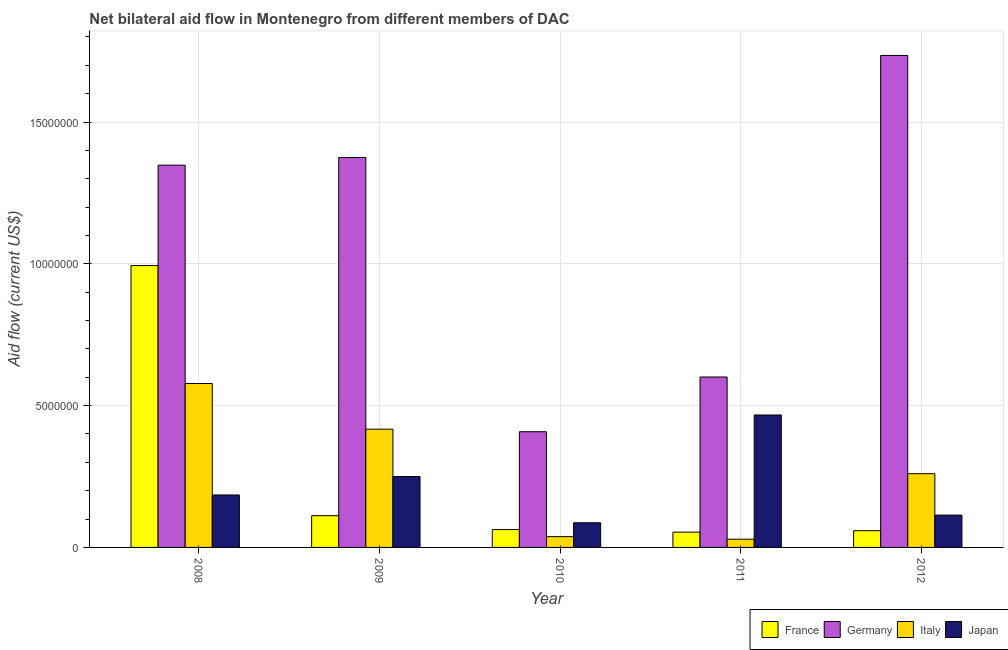How many different coloured bars are there?
Your answer should be compact. 4. Are the number of bars per tick equal to the number of legend labels?
Keep it short and to the point. Yes. How many bars are there on the 2nd tick from the left?
Keep it short and to the point. 4. How many bars are there on the 5th tick from the right?
Your answer should be very brief. 4. In how many cases, is the number of bars for a given year not equal to the number of legend labels?
Your answer should be very brief. 0. What is the amount of aid given by italy in 2010?
Keep it short and to the point. 3.80e+05. Across all years, what is the maximum amount of aid given by japan?
Give a very brief answer. 4.67e+06. Across all years, what is the minimum amount of aid given by italy?
Offer a terse response. 2.90e+05. What is the total amount of aid given by japan in the graph?
Your response must be concise. 1.10e+07. What is the difference between the amount of aid given by japan in 2008 and that in 2012?
Your response must be concise. 7.10e+05. What is the difference between the amount of aid given by france in 2012 and the amount of aid given by japan in 2011?
Give a very brief answer. 5.00e+04. What is the average amount of aid given by japan per year?
Ensure brevity in your answer.  2.21e+06. In the year 2009, what is the difference between the amount of aid given by france and amount of aid given by japan?
Offer a terse response. 0. What is the ratio of the amount of aid given by france in 2009 to that in 2011?
Provide a succinct answer. 2.07. Is the difference between the amount of aid given by japan in 2010 and 2011 greater than the difference between the amount of aid given by italy in 2010 and 2011?
Make the answer very short. No. What is the difference between the highest and the second highest amount of aid given by italy?
Provide a succinct answer. 1.61e+06. What is the difference between the highest and the lowest amount of aid given by germany?
Keep it short and to the point. 1.33e+07. Is it the case that in every year, the sum of the amount of aid given by france and amount of aid given by germany is greater than the amount of aid given by italy?
Your answer should be compact. Yes. What is the difference between two consecutive major ticks on the Y-axis?
Your answer should be compact. 5.00e+06. Does the graph contain grids?
Your response must be concise. Yes. How many legend labels are there?
Make the answer very short. 4. How are the legend labels stacked?
Provide a succinct answer. Horizontal. What is the title of the graph?
Give a very brief answer. Net bilateral aid flow in Montenegro from different members of DAC. Does "Regional development banks" appear as one of the legend labels in the graph?
Your response must be concise. No. What is the label or title of the Y-axis?
Your response must be concise. Aid flow (current US$). What is the Aid flow (current US$) of France in 2008?
Your answer should be compact. 9.94e+06. What is the Aid flow (current US$) of Germany in 2008?
Your response must be concise. 1.35e+07. What is the Aid flow (current US$) of Italy in 2008?
Make the answer very short. 5.78e+06. What is the Aid flow (current US$) of Japan in 2008?
Provide a succinct answer. 1.85e+06. What is the Aid flow (current US$) in France in 2009?
Your response must be concise. 1.12e+06. What is the Aid flow (current US$) of Germany in 2009?
Provide a succinct answer. 1.38e+07. What is the Aid flow (current US$) of Italy in 2009?
Your answer should be very brief. 4.17e+06. What is the Aid flow (current US$) in Japan in 2009?
Ensure brevity in your answer.  2.50e+06. What is the Aid flow (current US$) of France in 2010?
Your answer should be very brief. 6.30e+05. What is the Aid flow (current US$) of Germany in 2010?
Make the answer very short. 4.08e+06. What is the Aid flow (current US$) of Italy in 2010?
Give a very brief answer. 3.80e+05. What is the Aid flow (current US$) of Japan in 2010?
Provide a short and direct response. 8.70e+05. What is the Aid flow (current US$) of France in 2011?
Make the answer very short. 5.40e+05. What is the Aid flow (current US$) in Germany in 2011?
Provide a short and direct response. 6.01e+06. What is the Aid flow (current US$) in Japan in 2011?
Your answer should be compact. 4.67e+06. What is the Aid flow (current US$) of France in 2012?
Provide a succinct answer. 5.90e+05. What is the Aid flow (current US$) of Germany in 2012?
Give a very brief answer. 1.74e+07. What is the Aid flow (current US$) in Italy in 2012?
Make the answer very short. 2.60e+06. What is the Aid flow (current US$) of Japan in 2012?
Offer a very short reply. 1.14e+06. Across all years, what is the maximum Aid flow (current US$) of France?
Your answer should be very brief. 9.94e+06. Across all years, what is the maximum Aid flow (current US$) in Germany?
Provide a succinct answer. 1.74e+07. Across all years, what is the maximum Aid flow (current US$) in Italy?
Offer a very short reply. 5.78e+06. Across all years, what is the maximum Aid flow (current US$) of Japan?
Give a very brief answer. 4.67e+06. Across all years, what is the minimum Aid flow (current US$) in France?
Make the answer very short. 5.40e+05. Across all years, what is the minimum Aid flow (current US$) in Germany?
Offer a very short reply. 4.08e+06. Across all years, what is the minimum Aid flow (current US$) of Italy?
Provide a short and direct response. 2.90e+05. Across all years, what is the minimum Aid flow (current US$) of Japan?
Your answer should be very brief. 8.70e+05. What is the total Aid flow (current US$) in France in the graph?
Your response must be concise. 1.28e+07. What is the total Aid flow (current US$) of Germany in the graph?
Your answer should be compact. 5.47e+07. What is the total Aid flow (current US$) in Italy in the graph?
Your answer should be compact. 1.32e+07. What is the total Aid flow (current US$) of Japan in the graph?
Provide a short and direct response. 1.10e+07. What is the difference between the Aid flow (current US$) in France in 2008 and that in 2009?
Offer a very short reply. 8.82e+06. What is the difference between the Aid flow (current US$) in Italy in 2008 and that in 2009?
Provide a succinct answer. 1.61e+06. What is the difference between the Aid flow (current US$) of Japan in 2008 and that in 2009?
Make the answer very short. -6.50e+05. What is the difference between the Aid flow (current US$) of France in 2008 and that in 2010?
Provide a succinct answer. 9.31e+06. What is the difference between the Aid flow (current US$) in Germany in 2008 and that in 2010?
Provide a succinct answer. 9.40e+06. What is the difference between the Aid flow (current US$) in Italy in 2008 and that in 2010?
Keep it short and to the point. 5.40e+06. What is the difference between the Aid flow (current US$) of Japan in 2008 and that in 2010?
Give a very brief answer. 9.80e+05. What is the difference between the Aid flow (current US$) in France in 2008 and that in 2011?
Keep it short and to the point. 9.40e+06. What is the difference between the Aid flow (current US$) of Germany in 2008 and that in 2011?
Make the answer very short. 7.47e+06. What is the difference between the Aid flow (current US$) in Italy in 2008 and that in 2011?
Provide a succinct answer. 5.49e+06. What is the difference between the Aid flow (current US$) in Japan in 2008 and that in 2011?
Make the answer very short. -2.82e+06. What is the difference between the Aid flow (current US$) in France in 2008 and that in 2012?
Your answer should be compact. 9.35e+06. What is the difference between the Aid flow (current US$) in Germany in 2008 and that in 2012?
Offer a terse response. -3.87e+06. What is the difference between the Aid flow (current US$) in Italy in 2008 and that in 2012?
Your response must be concise. 3.18e+06. What is the difference between the Aid flow (current US$) in Japan in 2008 and that in 2012?
Offer a very short reply. 7.10e+05. What is the difference between the Aid flow (current US$) in France in 2009 and that in 2010?
Offer a very short reply. 4.90e+05. What is the difference between the Aid flow (current US$) in Germany in 2009 and that in 2010?
Make the answer very short. 9.67e+06. What is the difference between the Aid flow (current US$) of Italy in 2009 and that in 2010?
Make the answer very short. 3.79e+06. What is the difference between the Aid flow (current US$) of Japan in 2009 and that in 2010?
Ensure brevity in your answer.  1.63e+06. What is the difference between the Aid flow (current US$) in France in 2009 and that in 2011?
Provide a short and direct response. 5.80e+05. What is the difference between the Aid flow (current US$) of Germany in 2009 and that in 2011?
Your answer should be very brief. 7.74e+06. What is the difference between the Aid flow (current US$) of Italy in 2009 and that in 2011?
Keep it short and to the point. 3.88e+06. What is the difference between the Aid flow (current US$) of Japan in 2009 and that in 2011?
Your answer should be very brief. -2.17e+06. What is the difference between the Aid flow (current US$) of France in 2009 and that in 2012?
Give a very brief answer. 5.30e+05. What is the difference between the Aid flow (current US$) of Germany in 2009 and that in 2012?
Your answer should be very brief. -3.60e+06. What is the difference between the Aid flow (current US$) in Italy in 2009 and that in 2012?
Keep it short and to the point. 1.57e+06. What is the difference between the Aid flow (current US$) in Japan in 2009 and that in 2012?
Your response must be concise. 1.36e+06. What is the difference between the Aid flow (current US$) of France in 2010 and that in 2011?
Offer a very short reply. 9.00e+04. What is the difference between the Aid flow (current US$) in Germany in 2010 and that in 2011?
Give a very brief answer. -1.93e+06. What is the difference between the Aid flow (current US$) in Japan in 2010 and that in 2011?
Your answer should be compact. -3.80e+06. What is the difference between the Aid flow (current US$) of France in 2010 and that in 2012?
Offer a terse response. 4.00e+04. What is the difference between the Aid flow (current US$) of Germany in 2010 and that in 2012?
Offer a terse response. -1.33e+07. What is the difference between the Aid flow (current US$) in Italy in 2010 and that in 2012?
Ensure brevity in your answer.  -2.22e+06. What is the difference between the Aid flow (current US$) of Japan in 2010 and that in 2012?
Keep it short and to the point. -2.70e+05. What is the difference between the Aid flow (current US$) in France in 2011 and that in 2012?
Offer a terse response. -5.00e+04. What is the difference between the Aid flow (current US$) of Germany in 2011 and that in 2012?
Provide a short and direct response. -1.13e+07. What is the difference between the Aid flow (current US$) of Italy in 2011 and that in 2012?
Offer a terse response. -2.31e+06. What is the difference between the Aid flow (current US$) of Japan in 2011 and that in 2012?
Keep it short and to the point. 3.53e+06. What is the difference between the Aid flow (current US$) of France in 2008 and the Aid flow (current US$) of Germany in 2009?
Provide a succinct answer. -3.81e+06. What is the difference between the Aid flow (current US$) in France in 2008 and the Aid flow (current US$) in Italy in 2009?
Give a very brief answer. 5.77e+06. What is the difference between the Aid flow (current US$) in France in 2008 and the Aid flow (current US$) in Japan in 2009?
Ensure brevity in your answer.  7.44e+06. What is the difference between the Aid flow (current US$) of Germany in 2008 and the Aid flow (current US$) of Italy in 2009?
Offer a very short reply. 9.31e+06. What is the difference between the Aid flow (current US$) of Germany in 2008 and the Aid flow (current US$) of Japan in 2009?
Provide a succinct answer. 1.10e+07. What is the difference between the Aid flow (current US$) in Italy in 2008 and the Aid flow (current US$) in Japan in 2009?
Your response must be concise. 3.28e+06. What is the difference between the Aid flow (current US$) in France in 2008 and the Aid flow (current US$) in Germany in 2010?
Your answer should be compact. 5.86e+06. What is the difference between the Aid flow (current US$) of France in 2008 and the Aid flow (current US$) of Italy in 2010?
Your answer should be compact. 9.56e+06. What is the difference between the Aid flow (current US$) of France in 2008 and the Aid flow (current US$) of Japan in 2010?
Give a very brief answer. 9.07e+06. What is the difference between the Aid flow (current US$) in Germany in 2008 and the Aid flow (current US$) in Italy in 2010?
Make the answer very short. 1.31e+07. What is the difference between the Aid flow (current US$) of Germany in 2008 and the Aid flow (current US$) of Japan in 2010?
Ensure brevity in your answer.  1.26e+07. What is the difference between the Aid flow (current US$) in Italy in 2008 and the Aid flow (current US$) in Japan in 2010?
Your answer should be very brief. 4.91e+06. What is the difference between the Aid flow (current US$) of France in 2008 and the Aid flow (current US$) of Germany in 2011?
Keep it short and to the point. 3.93e+06. What is the difference between the Aid flow (current US$) in France in 2008 and the Aid flow (current US$) in Italy in 2011?
Your response must be concise. 9.65e+06. What is the difference between the Aid flow (current US$) of France in 2008 and the Aid flow (current US$) of Japan in 2011?
Keep it short and to the point. 5.27e+06. What is the difference between the Aid flow (current US$) in Germany in 2008 and the Aid flow (current US$) in Italy in 2011?
Your answer should be compact. 1.32e+07. What is the difference between the Aid flow (current US$) of Germany in 2008 and the Aid flow (current US$) of Japan in 2011?
Ensure brevity in your answer.  8.81e+06. What is the difference between the Aid flow (current US$) in Italy in 2008 and the Aid flow (current US$) in Japan in 2011?
Your response must be concise. 1.11e+06. What is the difference between the Aid flow (current US$) in France in 2008 and the Aid flow (current US$) in Germany in 2012?
Provide a short and direct response. -7.41e+06. What is the difference between the Aid flow (current US$) of France in 2008 and the Aid flow (current US$) of Italy in 2012?
Provide a succinct answer. 7.34e+06. What is the difference between the Aid flow (current US$) in France in 2008 and the Aid flow (current US$) in Japan in 2012?
Give a very brief answer. 8.80e+06. What is the difference between the Aid flow (current US$) of Germany in 2008 and the Aid flow (current US$) of Italy in 2012?
Give a very brief answer. 1.09e+07. What is the difference between the Aid flow (current US$) in Germany in 2008 and the Aid flow (current US$) in Japan in 2012?
Ensure brevity in your answer.  1.23e+07. What is the difference between the Aid flow (current US$) of Italy in 2008 and the Aid flow (current US$) of Japan in 2012?
Make the answer very short. 4.64e+06. What is the difference between the Aid flow (current US$) of France in 2009 and the Aid flow (current US$) of Germany in 2010?
Offer a terse response. -2.96e+06. What is the difference between the Aid flow (current US$) in France in 2009 and the Aid flow (current US$) in Italy in 2010?
Give a very brief answer. 7.40e+05. What is the difference between the Aid flow (current US$) of Germany in 2009 and the Aid flow (current US$) of Italy in 2010?
Provide a short and direct response. 1.34e+07. What is the difference between the Aid flow (current US$) in Germany in 2009 and the Aid flow (current US$) in Japan in 2010?
Your answer should be very brief. 1.29e+07. What is the difference between the Aid flow (current US$) of Italy in 2009 and the Aid flow (current US$) of Japan in 2010?
Your answer should be very brief. 3.30e+06. What is the difference between the Aid flow (current US$) in France in 2009 and the Aid flow (current US$) in Germany in 2011?
Offer a terse response. -4.89e+06. What is the difference between the Aid flow (current US$) in France in 2009 and the Aid flow (current US$) in Italy in 2011?
Provide a succinct answer. 8.30e+05. What is the difference between the Aid flow (current US$) in France in 2009 and the Aid flow (current US$) in Japan in 2011?
Your response must be concise. -3.55e+06. What is the difference between the Aid flow (current US$) of Germany in 2009 and the Aid flow (current US$) of Italy in 2011?
Ensure brevity in your answer.  1.35e+07. What is the difference between the Aid flow (current US$) in Germany in 2009 and the Aid flow (current US$) in Japan in 2011?
Provide a succinct answer. 9.08e+06. What is the difference between the Aid flow (current US$) of Italy in 2009 and the Aid flow (current US$) of Japan in 2011?
Your response must be concise. -5.00e+05. What is the difference between the Aid flow (current US$) in France in 2009 and the Aid flow (current US$) in Germany in 2012?
Your answer should be very brief. -1.62e+07. What is the difference between the Aid flow (current US$) of France in 2009 and the Aid flow (current US$) of Italy in 2012?
Offer a very short reply. -1.48e+06. What is the difference between the Aid flow (current US$) in France in 2009 and the Aid flow (current US$) in Japan in 2012?
Offer a terse response. -2.00e+04. What is the difference between the Aid flow (current US$) in Germany in 2009 and the Aid flow (current US$) in Italy in 2012?
Provide a short and direct response. 1.12e+07. What is the difference between the Aid flow (current US$) in Germany in 2009 and the Aid flow (current US$) in Japan in 2012?
Keep it short and to the point. 1.26e+07. What is the difference between the Aid flow (current US$) of Italy in 2009 and the Aid flow (current US$) of Japan in 2012?
Offer a terse response. 3.03e+06. What is the difference between the Aid flow (current US$) in France in 2010 and the Aid flow (current US$) in Germany in 2011?
Keep it short and to the point. -5.38e+06. What is the difference between the Aid flow (current US$) in France in 2010 and the Aid flow (current US$) in Japan in 2011?
Offer a terse response. -4.04e+06. What is the difference between the Aid flow (current US$) in Germany in 2010 and the Aid flow (current US$) in Italy in 2011?
Ensure brevity in your answer.  3.79e+06. What is the difference between the Aid flow (current US$) of Germany in 2010 and the Aid flow (current US$) of Japan in 2011?
Ensure brevity in your answer.  -5.90e+05. What is the difference between the Aid flow (current US$) of Italy in 2010 and the Aid flow (current US$) of Japan in 2011?
Your response must be concise. -4.29e+06. What is the difference between the Aid flow (current US$) of France in 2010 and the Aid flow (current US$) of Germany in 2012?
Your answer should be very brief. -1.67e+07. What is the difference between the Aid flow (current US$) of France in 2010 and the Aid flow (current US$) of Italy in 2012?
Your answer should be very brief. -1.97e+06. What is the difference between the Aid flow (current US$) of France in 2010 and the Aid flow (current US$) of Japan in 2012?
Provide a short and direct response. -5.10e+05. What is the difference between the Aid flow (current US$) in Germany in 2010 and the Aid flow (current US$) in Italy in 2012?
Your response must be concise. 1.48e+06. What is the difference between the Aid flow (current US$) of Germany in 2010 and the Aid flow (current US$) of Japan in 2012?
Provide a succinct answer. 2.94e+06. What is the difference between the Aid flow (current US$) in Italy in 2010 and the Aid flow (current US$) in Japan in 2012?
Provide a short and direct response. -7.60e+05. What is the difference between the Aid flow (current US$) of France in 2011 and the Aid flow (current US$) of Germany in 2012?
Keep it short and to the point. -1.68e+07. What is the difference between the Aid flow (current US$) of France in 2011 and the Aid flow (current US$) of Italy in 2012?
Provide a short and direct response. -2.06e+06. What is the difference between the Aid flow (current US$) of France in 2011 and the Aid flow (current US$) of Japan in 2012?
Keep it short and to the point. -6.00e+05. What is the difference between the Aid flow (current US$) in Germany in 2011 and the Aid flow (current US$) in Italy in 2012?
Give a very brief answer. 3.41e+06. What is the difference between the Aid flow (current US$) of Germany in 2011 and the Aid flow (current US$) of Japan in 2012?
Your answer should be very brief. 4.87e+06. What is the difference between the Aid flow (current US$) of Italy in 2011 and the Aid flow (current US$) of Japan in 2012?
Make the answer very short. -8.50e+05. What is the average Aid flow (current US$) of France per year?
Provide a succinct answer. 2.56e+06. What is the average Aid flow (current US$) in Germany per year?
Make the answer very short. 1.09e+07. What is the average Aid flow (current US$) in Italy per year?
Ensure brevity in your answer.  2.64e+06. What is the average Aid flow (current US$) of Japan per year?
Your response must be concise. 2.21e+06. In the year 2008, what is the difference between the Aid flow (current US$) of France and Aid flow (current US$) of Germany?
Your answer should be very brief. -3.54e+06. In the year 2008, what is the difference between the Aid flow (current US$) of France and Aid flow (current US$) of Italy?
Keep it short and to the point. 4.16e+06. In the year 2008, what is the difference between the Aid flow (current US$) of France and Aid flow (current US$) of Japan?
Your answer should be very brief. 8.09e+06. In the year 2008, what is the difference between the Aid flow (current US$) of Germany and Aid flow (current US$) of Italy?
Provide a short and direct response. 7.70e+06. In the year 2008, what is the difference between the Aid flow (current US$) of Germany and Aid flow (current US$) of Japan?
Offer a terse response. 1.16e+07. In the year 2008, what is the difference between the Aid flow (current US$) of Italy and Aid flow (current US$) of Japan?
Make the answer very short. 3.93e+06. In the year 2009, what is the difference between the Aid flow (current US$) in France and Aid flow (current US$) in Germany?
Provide a short and direct response. -1.26e+07. In the year 2009, what is the difference between the Aid flow (current US$) of France and Aid flow (current US$) of Italy?
Make the answer very short. -3.05e+06. In the year 2009, what is the difference between the Aid flow (current US$) in France and Aid flow (current US$) in Japan?
Your answer should be very brief. -1.38e+06. In the year 2009, what is the difference between the Aid flow (current US$) of Germany and Aid flow (current US$) of Italy?
Keep it short and to the point. 9.58e+06. In the year 2009, what is the difference between the Aid flow (current US$) in Germany and Aid flow (current US$) in Japan?
Keep it short and to the point. 1.12e+07. In the year 2009, what is the difference between the Aid flow (current US$) in Italy and Aid flow (current US$) in Japan?
Keep it short and to the point. 1.67e+06. In the year 2010, what is the difference between the Aid flow (current US$) in France and Aid flow (current US$) in Germany?
Your answer should be very brief. -3.45e+06. In the year 2010, what is the difference between the Aid flow (current US$) in Germany and Aid flow (current US$) in Italy?
Your answer should be compact. 3.70e+06. In the year 2010, what is the difference between the Aid flow (current US$) of Germany and Aid flow (current US$) of Japan?
Your response must be concise. 3.21e+06. In the year 2010, what is the difference between the Aid flow (current US$) in Italy and Aid flow (current US$) in Japan?
Provide a short and direct response. -4.90e+05. In the year 2011, what is the difference between the Aid flow (current US$) in France and Aid flow (current US$) in Germany?
Give a very brief answer. -5.47e+06. In the year 2011, what is the difference between the Aid flow (current US$) of France and Aid flow (current US$) of Japan?
Provide a short and direct response. -4.13e+06. In the year 2011, what is the difference between the Aid flow (current US$) of Germany and Aid flow (current US$) of Italy?
Provide a short and direct response. 5.72e+06. In the year 2011, what is the difference between the Aid flow (current US$) in Germany and Aid flow (current US$) in Japan?
Ensure brevity in your answer.  1.34e+06. In the year 2011, what is the difference between the Aid flow (current US$) in Italy and Aid flow (current US$) in Japan?
Your response must be concise. -4.38e+06. In the year 2012, what is the difference between the Aid flow (current US$) in France and Aid flow (current US$) in Germany?
Your response must be concise. -1.68e+07. In the year 2012, what is the difference between the Aid flow (current US$) of France and Aid flow (current US$) of Italy?
Offer a very short reply. -2.01e+06. In the year 2012, what is the difference between the Aid flow (current US$) in France and Aid flow (current US$) in Japan?
Offer a very short reply. -5.50e+05. In the year 2012, what is the difference between the Aid flow (current US$) of Germany and Aid flow (current US$) of Italy?
Ensure brevity in your answer.  1.48e+07. In the year 2012, what is the difference between the Aid flow (current US$) of Germany and Aid flow (current US$) of Japan?
Ensure brevity in your answer.  1.62e+07. In the year 2012, what is the difference between the Aid flow (current US$) of Italy and Aid flow (current US$) of Japan?
Make the answer very short. 1.46e+06. What is the ratio of the Aid flow (current US$) of France in 2008 to that in 2009?
Your answer should be very brief. 8.88. What is the ratio of the Aid flow (current US$) of Germany in 2008 to that in 2009?
Give a very brief answer. 0.98. What is the ratio of the Aid flow (current US$) in Italy in 2008 to that in 2009?
Your answer should be very brief. 1.39. What is the ratio of the Aid flow (current US$) of Japan in 2008 to that in 2009?
Offer a very short reply. 0.74. What is the ratio of the Aid flow (current US$) in France in 2008 to that in 2010?
Provide a short and direct response. 15.78. What is the ratio of the Aid flow (current US$) in Germany in 2008 to that in 2010?
Provide a short and direct response. 3.3. What is the ratio of the Aid flow (current US$) of Italy in 2008 to that in 2010?
Offer a very short reply. 15.21. What is the ratio of the Aid flow (current US$) in Japan in 2008 to that in 2010?
Your response must be concise. 2.13. What is the ratio of the Aid flow (current US$) in France in 2008 to that in 2011?
Your answer should be very brief. 18.41. What is the ratio of the Aid flow (current US$) of Germany in 2008 to that in 2011?
Your response must be concise. 2.24. What is the ratio of the Aid flow (current US$) in Italy in 2008 to that in 2011?
Offer a very short reply. 19.93. What is the ratio of the Aid flow (current US$) of Japan in 2008 to that in 2011?
Provide a short and direct response. 0.4. What is the ratio of the Aid flow (current US$) in France in 2008 to that in 2012?
Offer a very short reply. 16.85. What is the ratio of the Aid flow (current US$) of Germany in 2008 to that in 2012?
Keep it short and to the point. 0.78. What is the ratio of the Aid flow (current US$) of Italy in 2008 to that in 2012?
Offer a very short reply. 2.22. What is the ratio of the Aid flow (current US$) of Japan in 2008 to that in 2012?
Offer a very short reply. 1.62. What is the ratio of the Aid flow (current US$) of France in 2009 to that in 2010?
Your response must be concise. 1.78. What is the ratio of the Aid flow (current US$) in Germany in 2009 to that in 2010?
Your answer should be very brief. 3.37. What is the ratio of the Aid flow (current US$) in Italy in 2009 to that in 2010?
Your answer should be very brief. 10.97. What is the ratio of the Aid flow (current US$) of Japan in 2009 to that in 2010?
Give a very brief answer. 2.87. What is the ratio of the Aid flow (current US$) of France in 2009 to that in 2011?
Give a very brief answer. 2.07. What is the ratio of the Aid flow (current US$) in Germany in 2009 to that in 2011?
Your response must be concise. 2.29. What is the ratio of the Aid flow (current US$) in Italy in 2009 to that in 2011?
Your answer should be very brief. 14.38. What is the ratio of the Aid flow (current US$) in Japan in 2009 to that in 2011?
Your answer should be compact. 0.54. What is the ratio of the Aid flow (current US$) in France in 2009 to that in 2012?
Your answer should be very brief. 1.9. What is the ratio of the Aid flow (current US$) of Germany in 2009 to that in 2012?
Your answer should be very brief. 0.79. What is the ratio of the Aid flow (current US$) of Italy in 2009 to that in 2012?
Ensure brevity in your answer.  1.6. What is the ratio of the Aid flow (current US$) in Japan in 2009 to that in 2012?
Your answer should be compact. 2.19. What is the ratio of the Aid flow (current US$) in Germany in 2010 to that in 2011?
Your answer should be very brief. 0.68. What is the ratio of the Aid flow (current US$) of Italy in 2010 to that in 2011?
Your response must be concise. 1.31. What is the ratio of the Aid flow (current US$) in Japan in 2010 to that in 2011?
Keep it short and to the point. 0.19. What is the ratio of the Aid flow (current US$) in France in 2010 to that in 2012?
Make the answer very short. 1.07. What is the ratio of the Aid flow (current US$) of Germany in 2010 to that in 2012?
Make the answer very short. 0.24. What is the ratio of the Aid flow (current US$) in Italy in 2010 to that in 2012?
Offer a very short reply. 0.15. What is the ratio of the Aid flow (current US$) of Japan in 2010 to that in 2012?
Keep it short and to the point. 0.76. What is the ratio of the Aid flow (current US$) of France in 2011 to that in 2012?
Your response must be concise. 0.92. What is the ratio of the Aid flow (current US$) in Germany in 2011 to that in 2012?
Provide a short and direct response. 0.35. What is the ratio of the Aid flow (current US$) of Italy in 2011 to that in 2012?
Provide a succinct answer. 0.11. What is the ratio of the Aid flow (current US$) of Japan in 2011 to that in 2012?
Provide a succinct answer. 4.1. What is the difference between the highest and the second highest Aid flow (current US$) of France?
Provide a short and direct response. 8.82e+06. What is the difference between the highest and the second highest Aid flow (current US$) of Germany?
Provide a succinct answer. 3.60e+06. What is the difference between the highest and the second highest Aid flow (current US$) of Italy?
Your response must be concise. 1.61e+06. What is the difference between the highest and the second highest Aid flow (current US$) of Japan?
Keep it short and to the point. 2.17e+06. What is the difference between the highest and the lowest Aid flow (current US$) in France?
Offer a terse response. 9.40e+06. What is the difference between the highest and the lowest Aid flow (current US$) in Germany?
Offer a terse response. 1.33e+07. What is the difference between the highest and the lowest Aid flow (current US$) of Italy?
Give a very brief answer. 5.49e+06. What is the difference between the highest and the lowest Aid flow (current US$) in Japan?
Make the answer very short. 3.80e+06. 